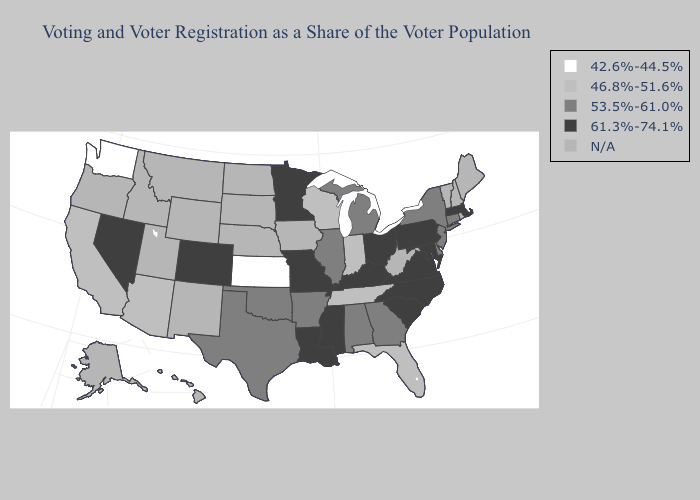Does the map have missing data?
Be succinct. Yes. Name the states that have a value in the range 53.5%-61.0%?
Keep it brief. Alabama, Arkansas, Connecticut, Delaware, Georgia, Illinois, Michigan, New Jersey, New York, Oklahoma, Texas. Does Mississippi have the highest value in the USA?
Short answer required. Yes. Does Massachusetts have the lowest value in the Northeast?
Short answer required. No. What is the highest value in states that border Kansas?
Be succinct. 61.3%-74.1%. What is the highest value in the USA?
Keep it brief. 61.3%-74.1%. What is the value of Hawaii?
Give a very brief answer. N/A. Among the states that border Delaware , does Pennsylvania have the highest value?
Quick response, please. Yes. Does Oklahoma have the lowest value in the USA?
Keep it brief. No. Name the states that have a value in the range 53.5%-61.0%?
Write a very short answer. Alabama, Arkansas, Connecticut, Delaware, Georgia, Illinois, Michigan, New Jersey, New York, Oklahoma, Texas. What is the value of Louisiana?
Be succinct. 61.3%-74.1%. Does Connecticut have the highest value in the Northeast?
Be succinct. No. Which states have the lowest value in the South?
Write a very short answer. Florida, Tennessee. 